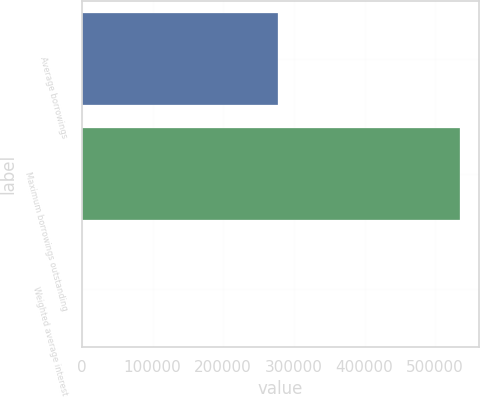Convert chart. <chart><loc_0><loc_0><loc_500><loc_500><bar_chart><fcel>Average borrowings<fcel>Maximum borrowings outstanding<fcel>Weighted average interest<nl><fcel>277952<fcel>534700<fcel>0.46<nl></chart> 